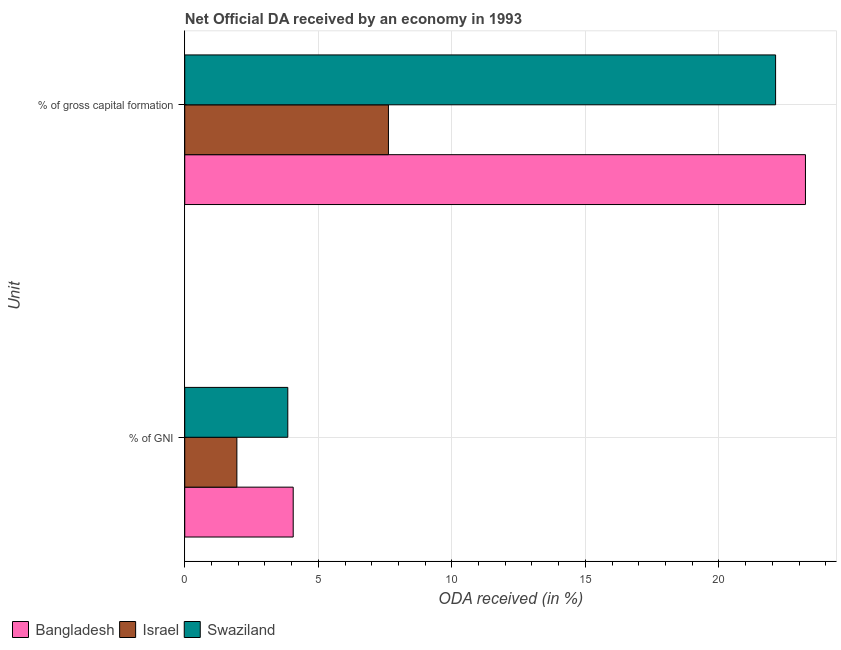How many different coloured bars are there?
Provide a short and direct response. 3. How many groups of bars are there?
Offer a very short reply. 2. Are the number of bars on each tick of the Y-axis equal?
Your response must be concise. Yes. What is the label of the 1st group of bars from the top?
Offer a very short reply. % of gross capital formation. What is the oda received as percentage of gni in Bangladesh?
Your response must be concise. 4.06. Across all countries, what is the maximum oda received as percentage of gni?
Provide a short and direct response. 4.06. Across all countries, what is the minimum oda received as percentage of gross capital formation?
Your answer should be compact. 7.63. In which country was the oda received as percentage of gross capital formation maximum?
Your answer should be very brief. Bangladesh. What is the total oda received as percentage of gross capital formation in the graph?
Your answer should be very brief. 52.99. What is the difference between the oda received as percentage of gni in Swaziland and that in Israel?
Provide a succinct answer. 1.91. What is the difference between the oda received as percentage of gross capital formation in Israel and the oda received as percentage of gni in Bangladesh?
Give a very brief answer. 3.57. What is the average oda received as percentage of gross capital formation per country?
Give a very brief answer. 17.66. What is the difference between the oda received as percentage of gross capital formation and oda received as percentage of gni in Swaziland?
Your answer should be compact. 18.26. In how many countries, is the oda received as percentage of gross capital formation greater than 15 %?
Keep it short and to the point. 2. What is the ratio of the oda received as percentage of gni in Swaziland to that in Bangladesh?
Offer a terse response. 0.95. In how many countries, is the oda received as percentage of gross capital formation greater than the average oda received as percentage of gross capital formation taken over all countries?
Provide a short and direct response. 2. How many bars are there?
Offer a terse response. 6. Are all the bars in the graph horizontal?
Ensure brevity in your answer.  Yes. What is the difference between two consecutive major ticks on the X-axis?
Offer a terse response. 5. Are the values on the major ticks of X-axis written in scientific E-notation?
Your response must be concise. No. Does the graph contain any zero values?
Your answer should be very brief. No. Does the graph contain grids?
Your response must be concise. Yes. Where does the legend appear in the graph?
Your response must be concise. Bottom left. How are the legend labels stacked?
Ensure brevity in your answer.  Horizontal. What is the title of the graph?
Keep it short and to the point. Net Official DA received by an economy in 1993. Does "Liberia" appear as one of the legend labels in the graph?
Keep it short and to the point. No. What is the label or title of the X-axis?
Your response must be concise. ODA received (in %). What is the label or title of the Y-axis?
Offer a terse response. Unit. What is the ODA received (in %) in Bangladesh in % of GNI?
Offer a terse response. 4.06. What is the ODA received (in %) of Israel in % of GNI?
Keep it short and to the point. 1.95. What is the ODA received (in %) of Swaziland in % of GNI?
Provide a succinct answer. 3.86. What is the ODA received (in %) of Bangladesh in % of gross capital formation?
Your answer should be very brief. 23.24. What is the ODA received (in %) in Israel in % of gross capital formation?
Ensure brevity in your answer.  7.63. What is the ODA received (in %) in Swaziland in % of gross capital formation?
Provide a short and direct response. 22.12. Across all Unit, what is the maximum ODA received (in %) in Bangladesh?
Your answer should be very brief. 23.24. Across all Unit, what is the maximum ODA received (in %) in Israel?
Ensure brevity in your answer.  7.63. Across all Unit, what is the maximum ODA received (in %) of Swaziland?
Offer a very short reply. 22.12. Across all Unit, what is the minimum ODA received (in %) of Bangladesh?
Ensure brevity in your answer.  4.06. Across all Unit, what is the minimum ODA received (in %) in Israel?
Provide a succinct answer. 1.95. Across all Unit, what is the minimum ODA received (in %) of Swaziland?
Your answer should be very brief. 3.86. What is the total ODA received (in %) in Bangladesh in the graph?
Make the answer very short. 27.3. What is the total ODA received (in %) in Israel in the graph?
Your response must be concise. 9.58. What is the total ODA received (in %) in Swaziland in the graph?
Your answer should be compact. 25.98. What is the difference between the ODA received (in %) of Bangladesh in % of GNI and that in % of gross capital formation?
Provide a succinct answer. -19.18. What is the difference between the ODA received (in %) of Israel in % of GNI and that in % of gross capital formation?
Your response must be concise. -5.67. What is the difference between the ODA received (in %) of Swaziland in % of GNI and that in % of gross capital formation?
Your answer should be very brief. -18.26. What is the difference between the ODA received (in %) in Bangladesh in % of GNI and the ODA received (in %) in Israel in % of gross capital formation?
Give a very brief answer. -3.57. What is the difference between the ODA received (in %) of Bangladesh in % of GNI and the ODA received (in %) of Swaziland in % of gross capital formation?
Ensure brevity in your answer.  -18.06. What is the difference between the ODA received (in %) in Israel in % of GNI and the ODA received (in %) in Swaziland in % of gross capital formation?
Provide a short and direct response. -20.17. What is the average ODA received (in %) of Bangladesh per Unit?
Provide a succinct answer. 13.65. What is the average ODA received (in %) in Israel per Unit?
Your response must be concise. 4.79. What is the average ODA received (in %) of Swaziland per Unit?
Provide a succinct answer. 12.99. What is the difference between the ODA received (in %) of Bangladesh and ODA received (in %) of Israel in % of GNI?
Make the answer very short. 2.11. What is the difference between the ODA received (in %) of Bangladesh and ODA received (in %) of Swaziland in % of GNI?
Make the answer very short. 0.2. What is the difference between the ODA received (in %) of Israel and ODA received (in %) of Swaziland in % of GNI?
Your answer should be very brief. -1.91. What is the difference between the ODA received (in %) of Bangladesh and ODA received (in %) of Israel in % of gross capital formation?
Give a very brief answer. 15.61. What is the difference between the ODA received (in %) of Bangladesh and ODA received (in %) of Swaziland in % of gross capital formation?
Your answer should be compact. 1.12. What is the difference between the ODA received (in %) in Israel and ODA received (in %) in Swaziland in % of gross capital formation?
Offer a very short reply. -14.49. What is the ratio of the ODA received (in %) of Bangladesh in % of GNI to that in % of gross capital formation?
Provide a short and direct response. 0.17. What is the ratio of the ODA received (in %) in Israel in % of GNI to that in % of gross capital formation?
Provide a short and direct response. 0.26. What is the ratio of the ODA received (in %) in Swaziland in % of GNI to that in % of gross capital formation?
Offer a very short reply. 0.17. What is the difference between the highest and the second highest ODA received (in %) of Bangladesh?
Make the answer very short. 19.18. What is the difference between the highest and the second highest ODA received (in %) of Israel?
Provide a short and direct response. 5.67. What is the difference between the highest and the second highest ODA received (in %) in Swaziland?
Offer a very short reply. 18.26. What is the difference between the highest and the lowest ODA received (in %) of Bangladesh?
Offer a very short reply. 19.18. What is the difference between the highest and the lowest ODA received (in %) of Israel?
Make the answer very short. 5.67. What is the difference between the highest and the lowest ODA received (in %) of Swaziland?
Give a very brief answer. 18.26. 